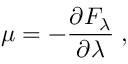Convert formula to latex. <formula><loc_0><loc_0><loc_500><loc_500>\mu = - \frac { \partial F _ { \lambda } } { \partial \lambda } \, ,</formula> 